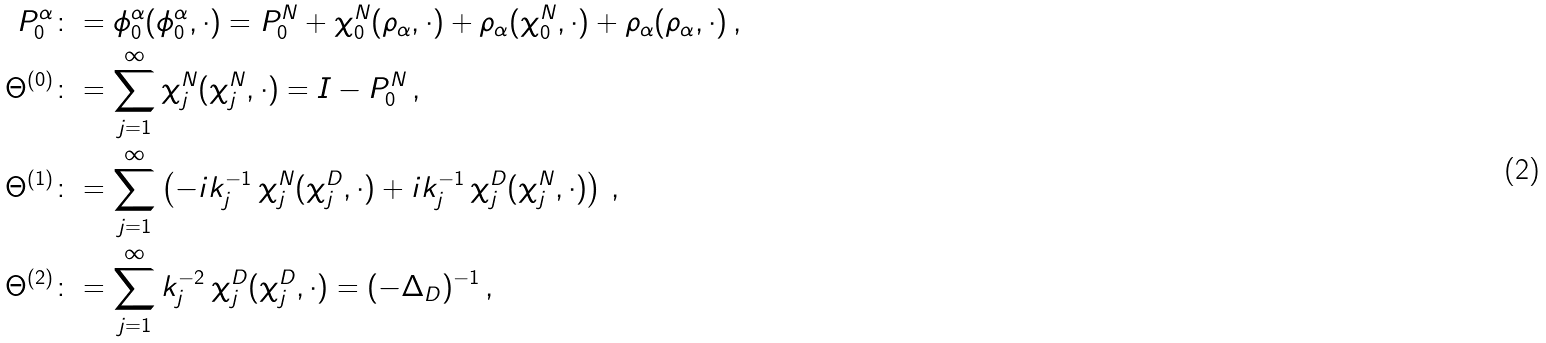Convert formula to latex. <formula><loc_0><loc_0><loc_500><loc_500>P _ { 0 } ^ { \alpha } & \colon = \phi _ { 0 } ^ { \alpha } ( \phi _ { 0 } ^ { \alpha } , \cdot ) = P _ { 0 } ^ { N } + \chi _ { 0 } ^ { N } ( \rho _ { \alpha } , \cdot ) + \rho _ { \alpha } ( \chi _ { 0 } ^ { N } , \cdot ) + \rho _ { \alpha } ( \rho _ { \alpha } , \cdot ) \, , \\ \Theta ^ { ( 0 ) } & \colon = \sum _ { j = 1 } ^ { \infty } \chi _ { j } ^ { N } ( \chi _ { j } ^ { N } , \cdot ) = I - P _ { 0 } ^ { N } \, , \\ \Theta ^ { ( 1 ) } & \colon = \sum _ { j = 1 } ^ { \infty } \left ( - i k _ { j } ^ { - 1 } \, \chi _ { j } ^ { N } ( \chi _ { j } ^ { D } , \cdot ) + i k _ { j } ^ { - 1 } \, \chi _ { j } ^ { D } ( \chi _ { j } ^ { N } , \cdot ) \right ) \, , \\ \Theta ^ { ( 2 ) } & \colon = \sum _ { j = 1 } ^ { \infty } k _ { j } ^ { - 2 } \, \chi _ { j } ^ { D } ( \chi _ { j } ^ { D } , \cdot ) = ( - \Delta _ { D } ) ^ { - 1 } \, ,</formula> 